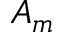Convert formula to latex. <formula><loc_0><loc_0><loc_500><loc_500>A _ { m }</formula> 